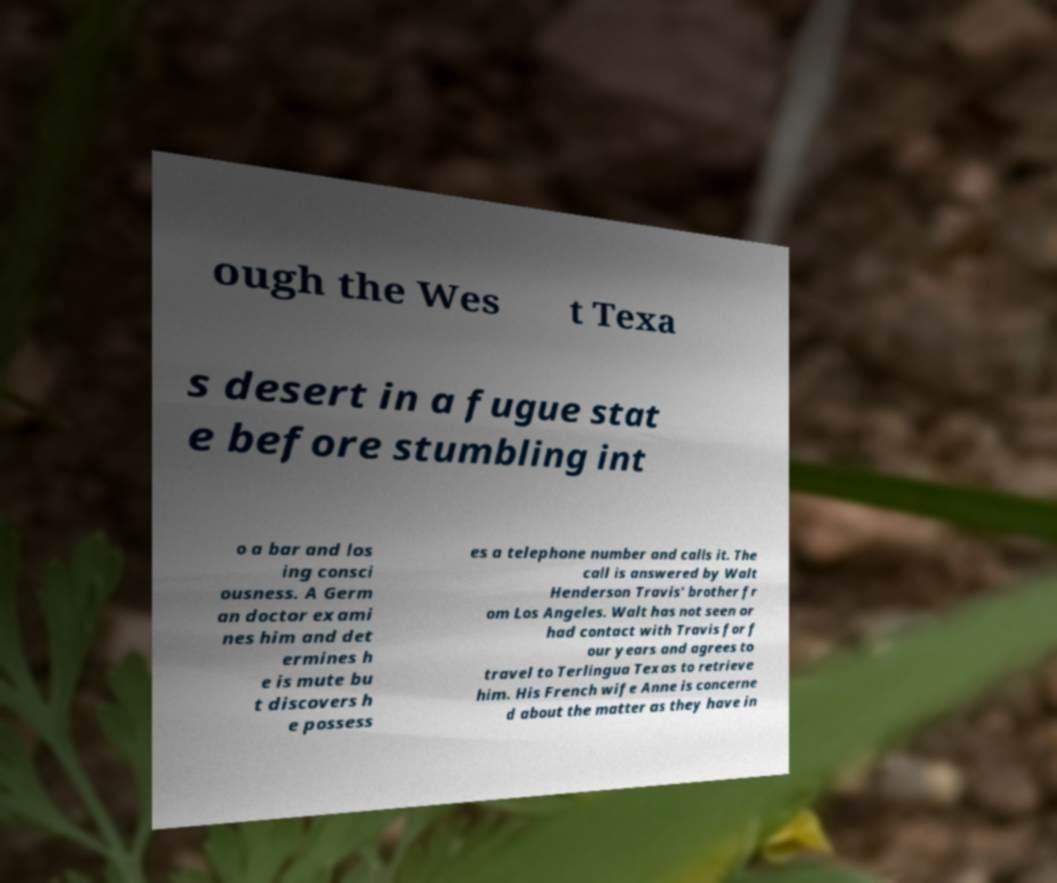For documentation purposes, I need the text within this image transcribed. Could you provide that? ough the Wes t Texa s desert in a fugue stat e before stumbling int o a bar and los ing consci ousness. A Germ an doctor exami nes him and det ermines h e is mute bu t discovers h e possess es a telephone number and calls it. The call is answered by Walt Henderson Travis' brother fr om Los Angeles. Walt has not seen or had contact with Travis for f our years and agrees to travel to Terlingua Texas to retrieve him. His French wife Anne is concerne d about the matter as they have in 